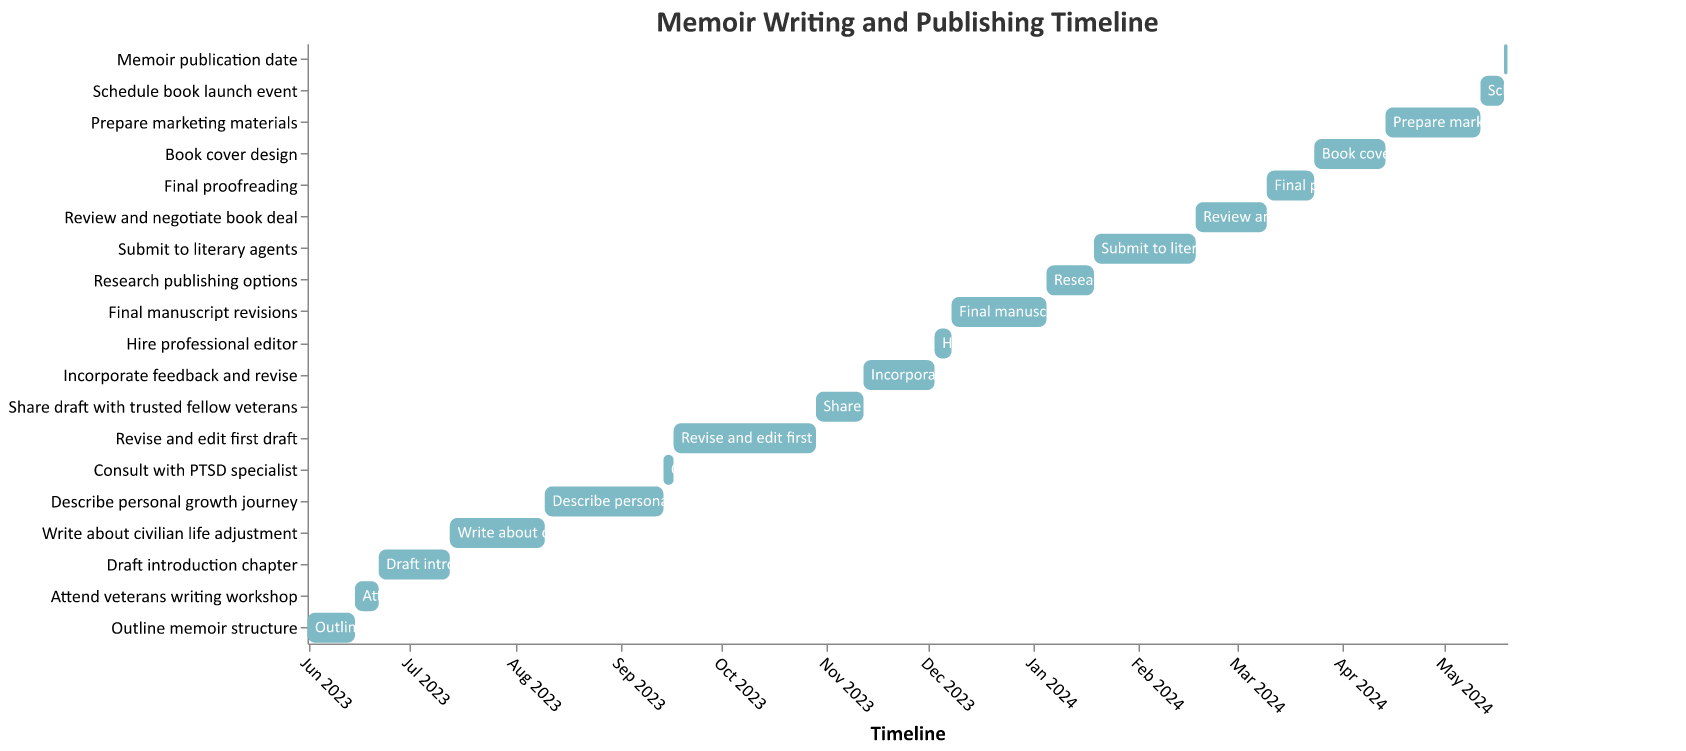How long is the entire process from outlining the memoir structure to the publication date? To calculate the entire process duration, find the difference between the start date of the first task and the end date of the last task. The first task starts on 2023-06-01 and the memoir publication date is 2024-05-19. The difference is 353 days.
Answer: 353 days Which task has the longest duration? The task with the longest duration is "Revise and edit first draft" which lasts for 42 days.
Answer: Revise and edit first draft How many tasks are there in total? Count the number of tasks listed in the Gantt Chart. There are 19 tasks in total.
Answer: 19 Does the task "Write about civilian life adjustment" overlap with "Describe personal growth journey"? Check the start and end dates for the tasks. "Write about civilian life adjustment" runs from 2023-07-13 to 2023-08-10, and "Describe personal growth journey" starts on 2023-08-10. The tasks do overlap on 2023-08-10.
Answer: Yes What is the time gap between sharing the draft with trusted fellow veterans and incorporating the feedback? "Share draft with trusted fellow veterans" ends on 2023-11-12 and "Incorporate feedback and revise" starts on the same day. Thus, there is no time gap.
Answer: No time gap What tasks are scheduled to start and finish in December 2023? Look at the tasks that start and finish within December 2023. "Hire professional editor" starts on 2023-12-03 and finishes on 2023-12-07, and "Final manuscript revisions" starts on 2023-12-08 and finishes on 2024-01-05.
Answer: Hire professional editor, Final manuscript revisions Compare the duration of "Draft introduction chapter" and "Write about civilian life adjustment". Which one takes more time? "Draft introduction chapter" lasts 21 days, while "Write about civilian life adjustment" lasts 28 days. The latter takes more time.
Answer: Write about civilian life adjustment How many weeks does it take to complete "Prepare marketing materials"? "Prepare marketing materials" lasts for 28 days, which is equivalent to 4 weeks (28 days / 7).
Answer: 4 weeks When does the "Review and negotiate book deal" task begin and end? "Review and negotiate book deal" starts on 2024-02-18 and ends on 2024-03-10.
Answer: 2024-02-18 to 2024-03-10 